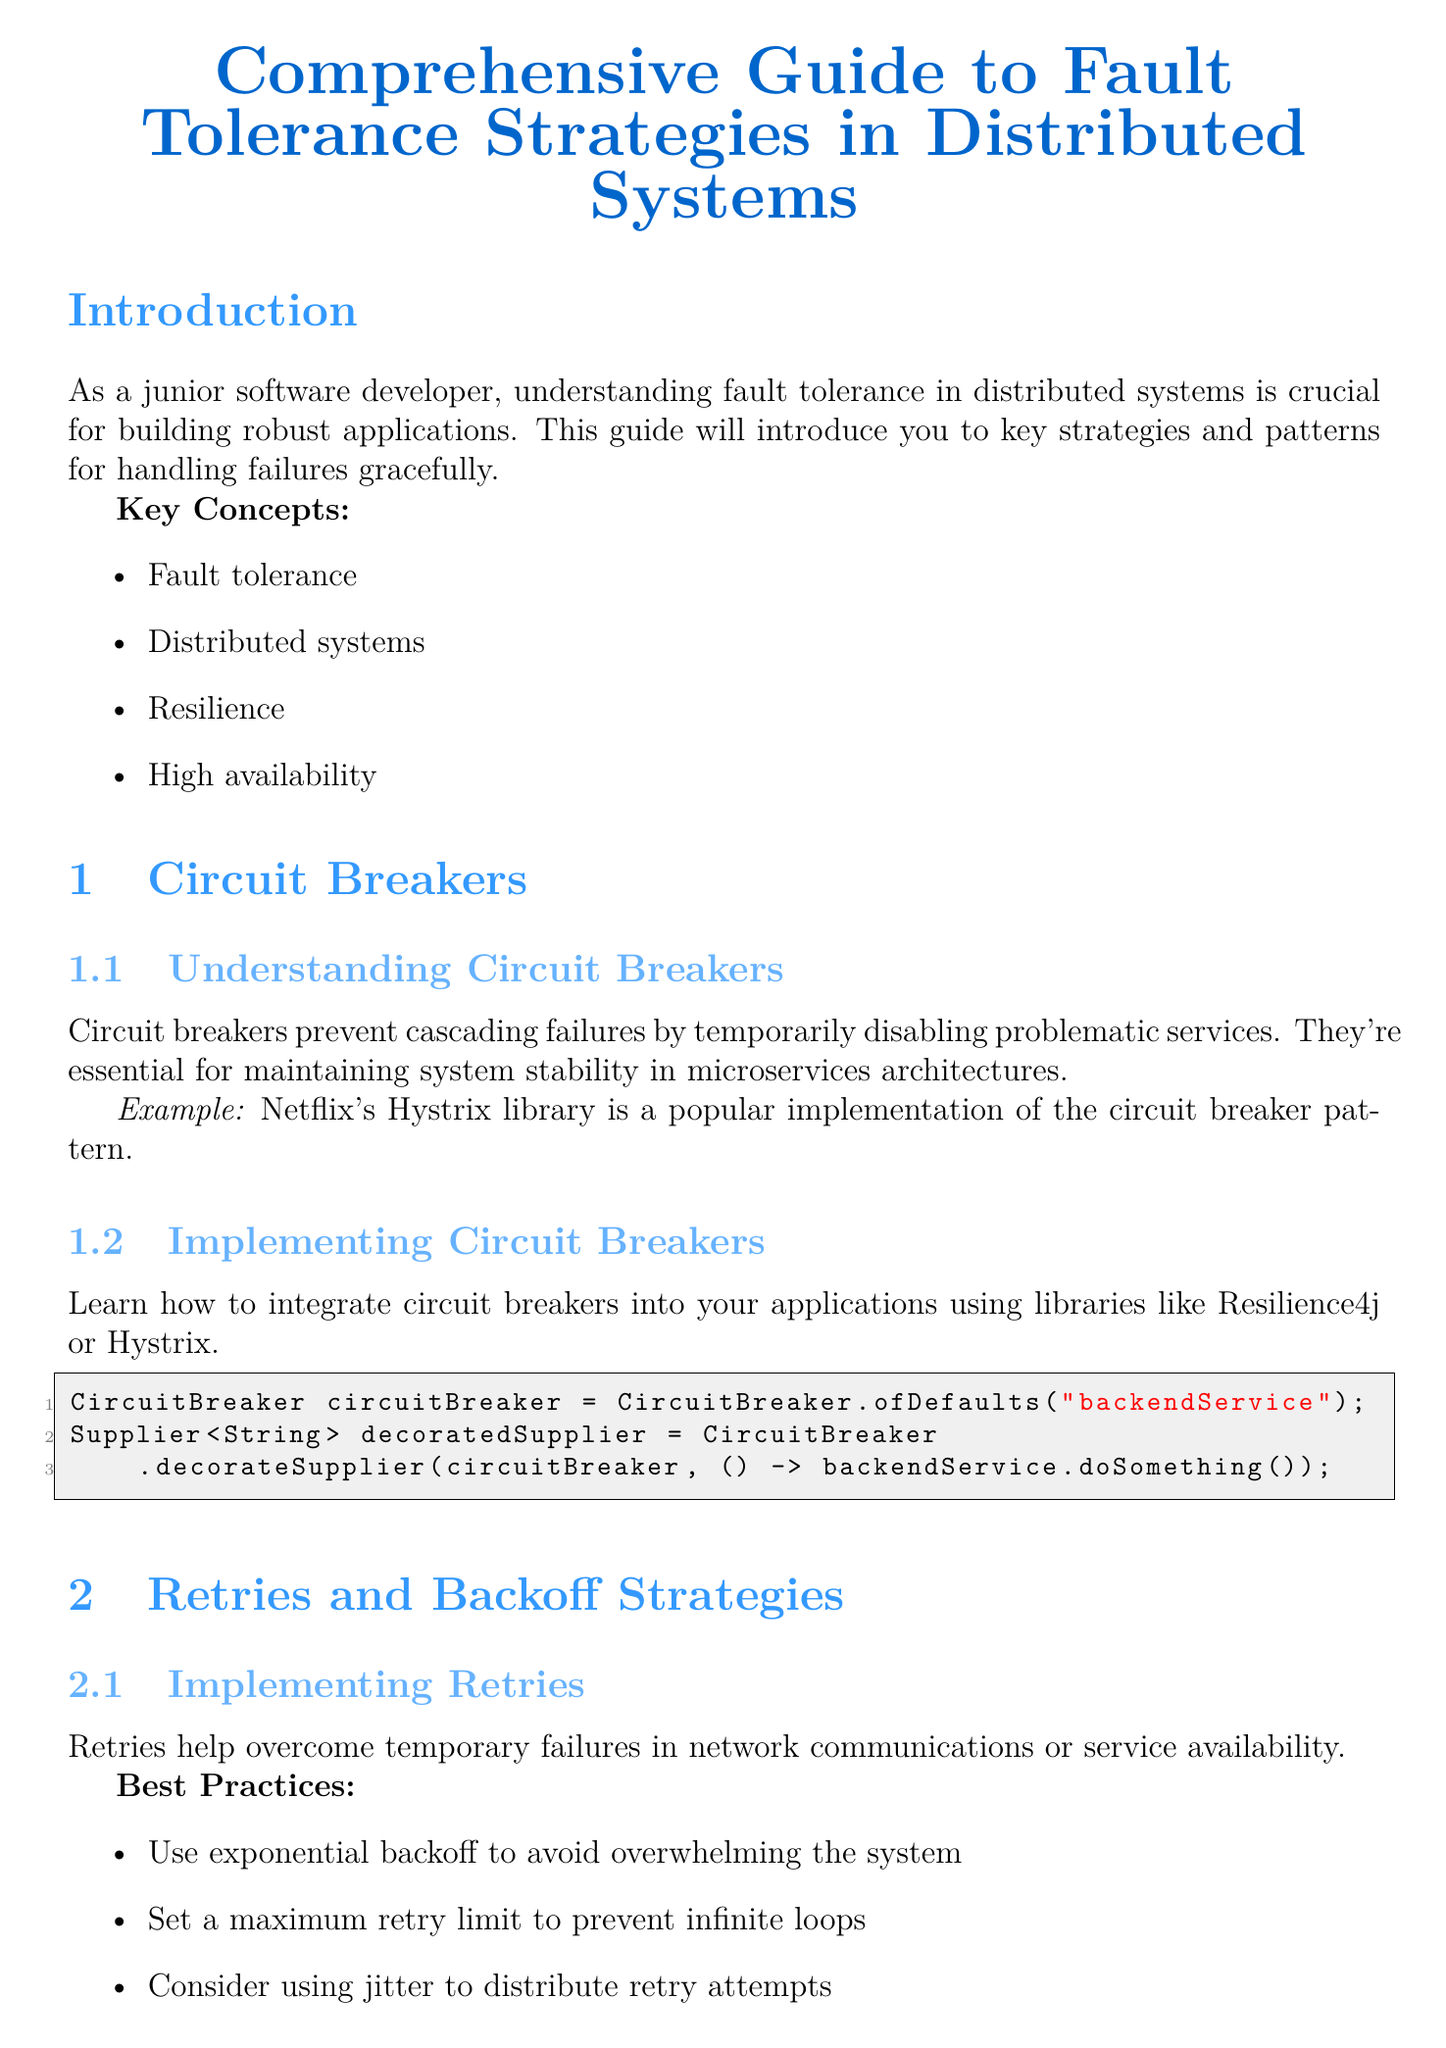What is the title of the guide? The title of the guide is stated at the beginning of the document.
Answer: Comprehensive Guide to Fault Tolerance Strategies in Distributed Systems What are the key concepts listed in the introduction? The document lists key concepts that are important for understanding fault tolerance.
Answer: Fault tolerance, Distributed systems, Resilience, High availability What library is mentioned as a popular implementation of the circuit breaker pattern? The document provides an example of a library that implements the circuit breaker pattern.
Answer: Netflix's Hystrix What are the three backoff strategies mentioned? The document outlines strategies for optimizing retry attempts.
Answer: Fixed backoff, Exponential backoff, Exponential backoff with jitter How many best practices are listed for implementing retries? The document provides a set of best practices for implementation.
Answer: Three What programming languages are utilized in the code snippets? The document includes code snippets for implementing circuit breakers and timeouts.
Answer: Java, Python What tools are recommended for effective monitoring? The document suggests tools that facilitate monitoring in distributed systems.
Answer: Prometheus, Grafana, ELK stack What is a benefit of using bulkheads? The document highlights the advantages of isolating components in applications.
Answer: Improved fault isolation What is one next step suggested in the conclusion? The document encourages further actions after learning about fault tolerance strategies.
Answer: Explore chaos engineering practices 